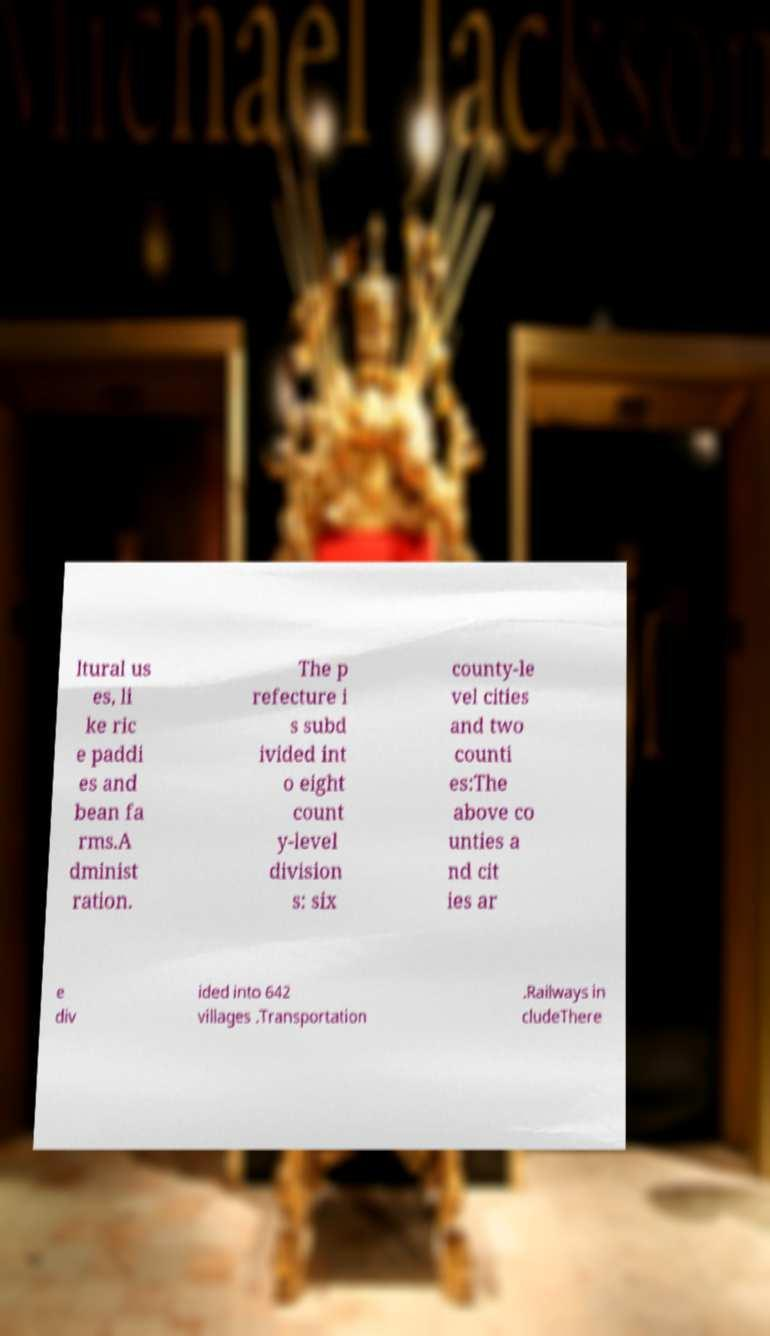Please identify and transcribe the text found in this image. ltural us es, li ke ric e paddi es and bean fa rms.A dminist ration. The p refecture i s subd ivided int o eight count y-level division s: six county-le vel cities and two counti es:The above co unties a nd cit ies ar e div ided into 642 villages .Transportation .Railways in cludeThere 